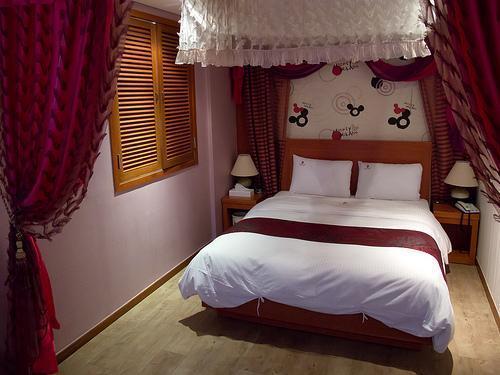How many beds are there?
Give a very brief answer. 1. 